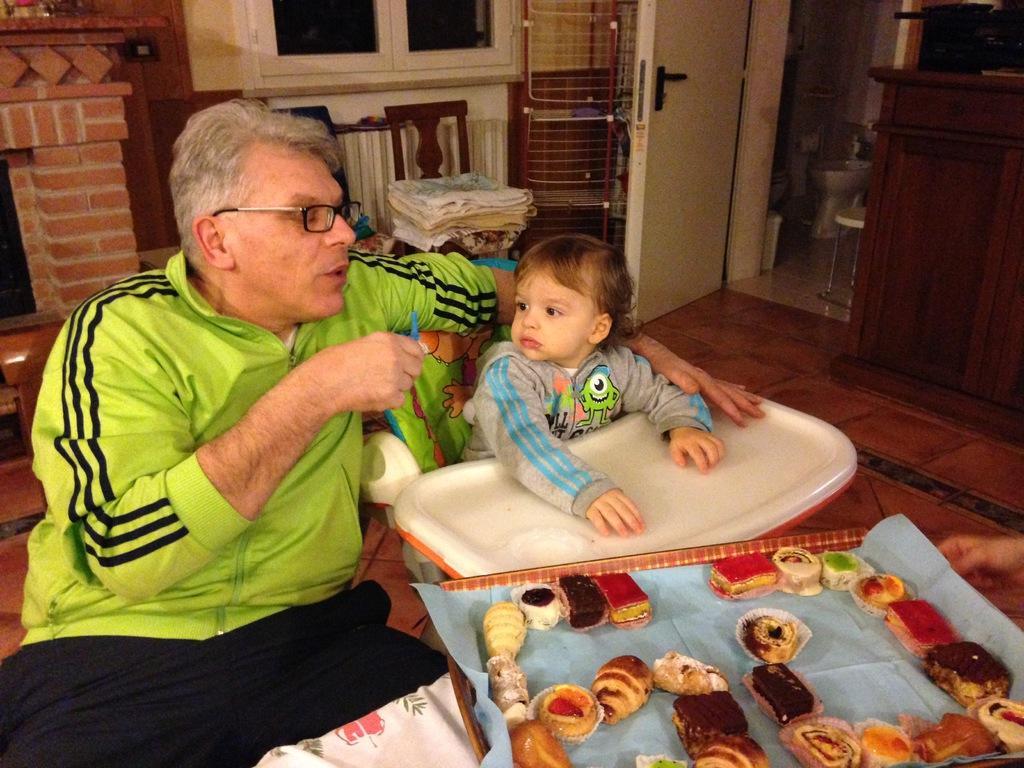In one or two sentences, can you explain what this image depicts? In this picture there is a man on the left side of the image and there is a small baby in a sitter and there are doors and windows at the top side of the image. 